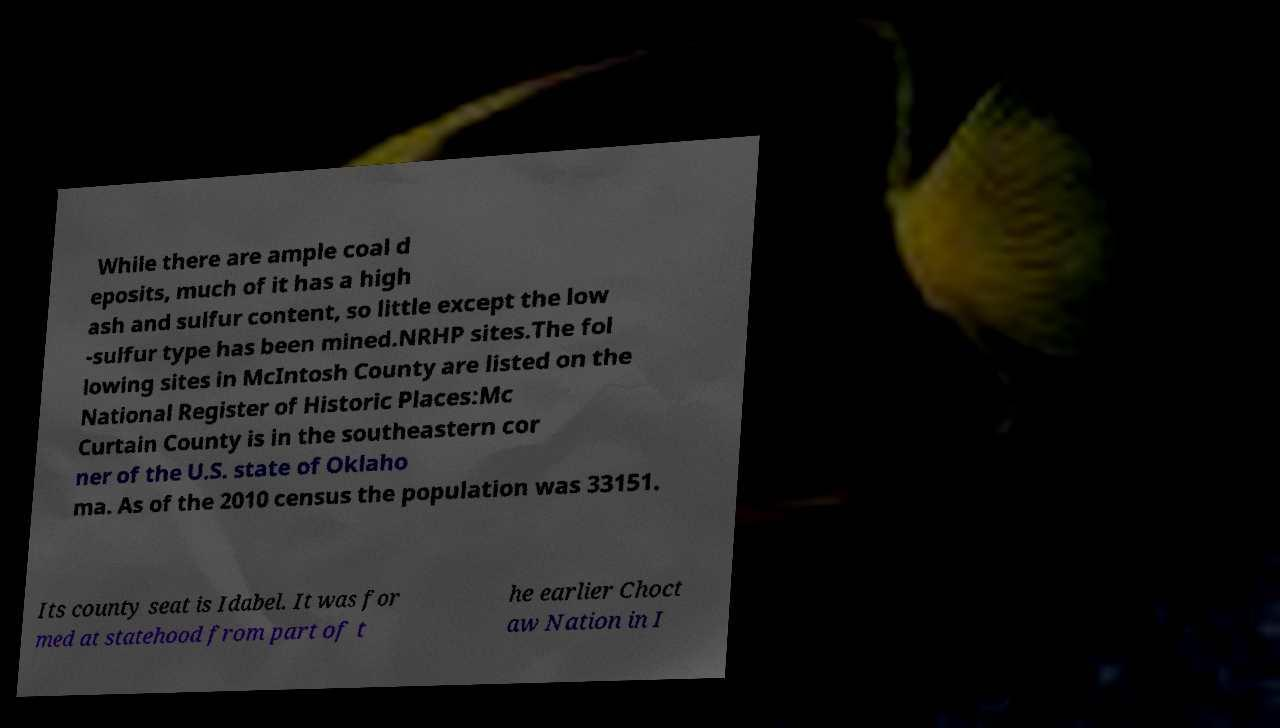Please identify and transcribe the text found in this image. While there are ample coal d eposits, much of it has a high ash and sulfur content, so little except the low -sulfur type has been mined.NRHP sites.The fol lowing sites in McIntosh County are listed on the National Register of Historic Places:Mc Curtain County is in the southeastern cor ner of the U.S. state of Oklaho ma. As of the 2010 census the population was 33151. Its county seat is Idabel. It was for med at statehood from part of t he earlier Choct aw Nation in I 